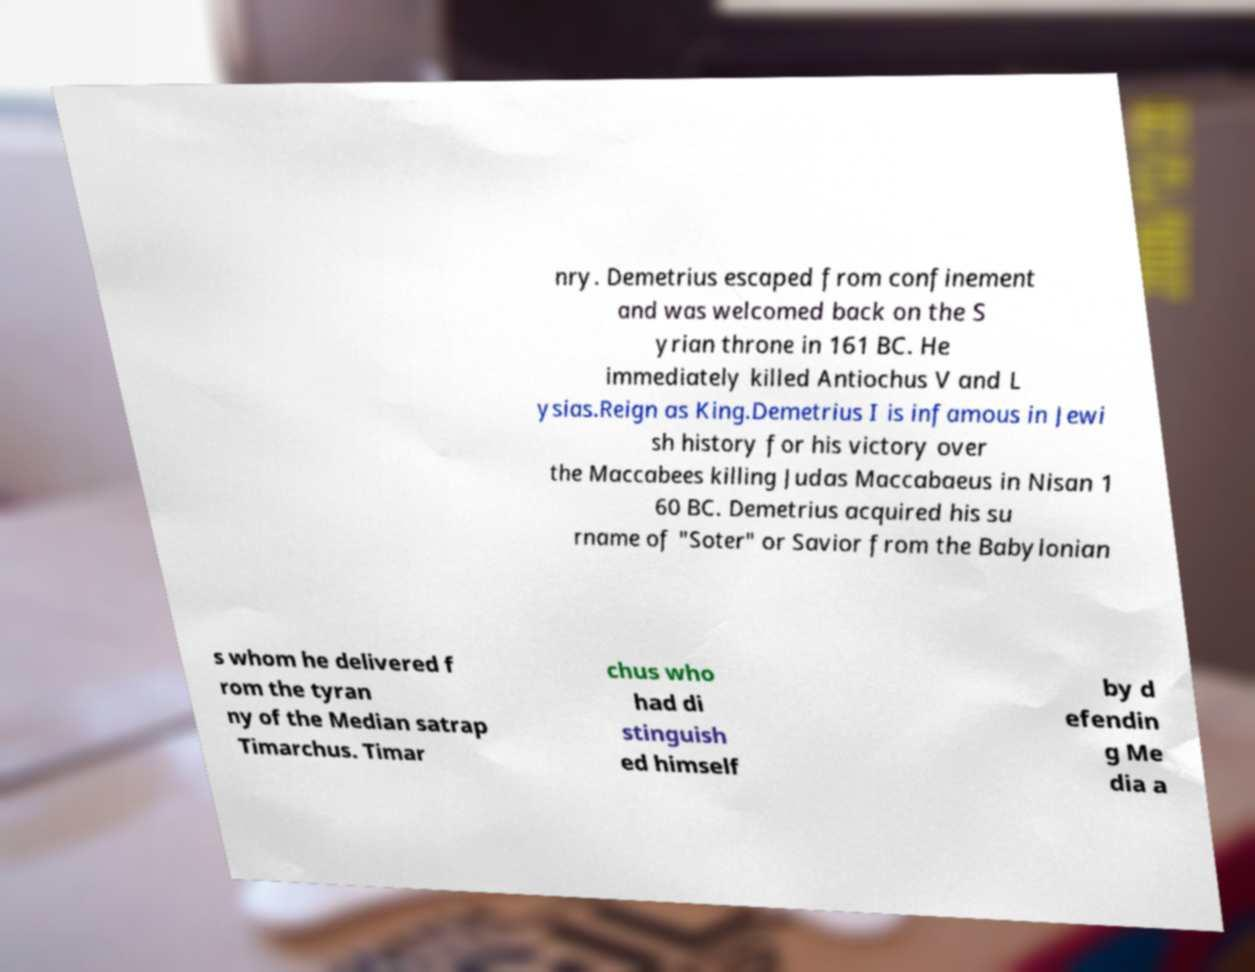Please read and relay the text visible in this image. What does it say? nry. Demetrius escaped from confinement and was welcomed back on the S yrian throne in 161 BC. He immediately killed Antiochus V and L ysias.Reign as King.Demetrius I is infamous in Jewi sh history for his victory over the Maccabees killing Judas Maccabaeus in Nisan 1 60 BC. Demetrius acquired his su rname of "Soter" or Savior from the Babylonian s whom he delivered f rom the tyran ny of the Median satrap Timarchus. Timar chus who had di stinguish ed himself by d efendin g Me dia a 